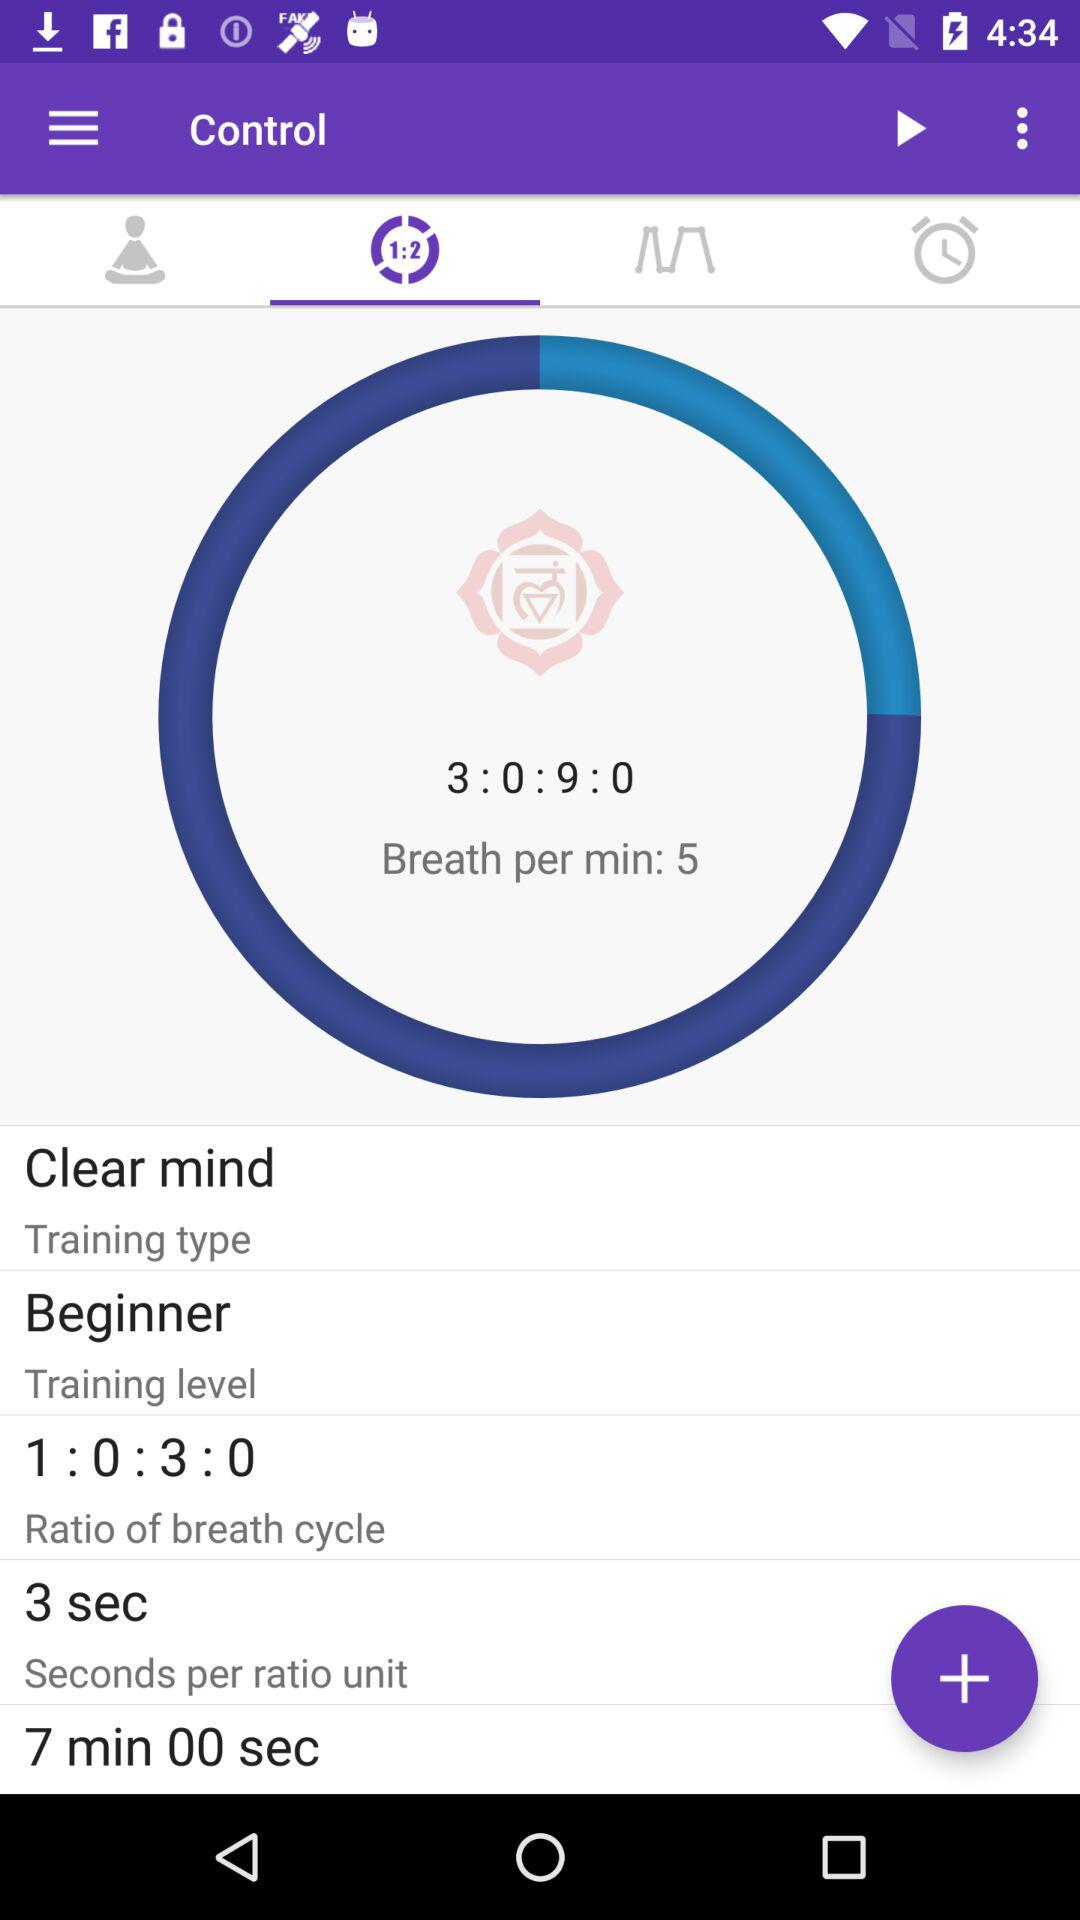What is the "Training type"? The type is "Clear mind". 